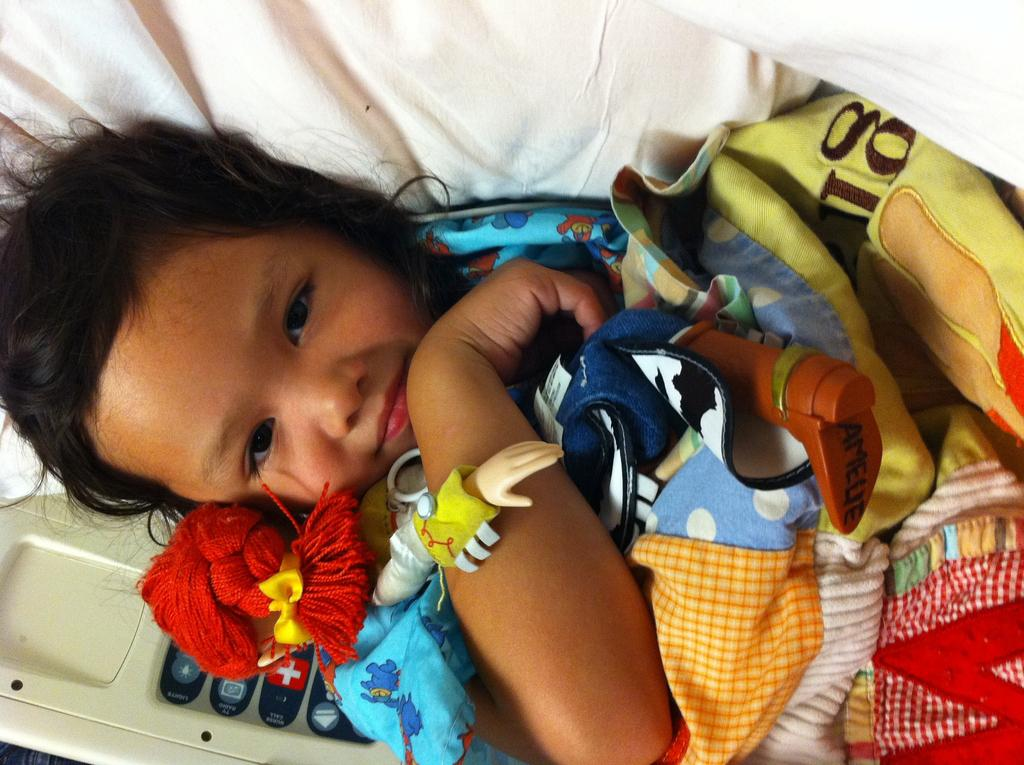Provide a one-sentence caption for the provided image. The bottom of the doll's boot reads Amelie. 